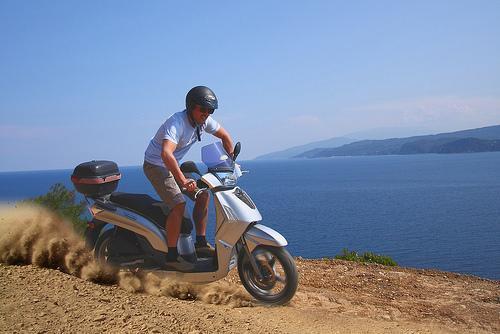How many people are riding bike on sand?
Give a very brief answer. 0. 